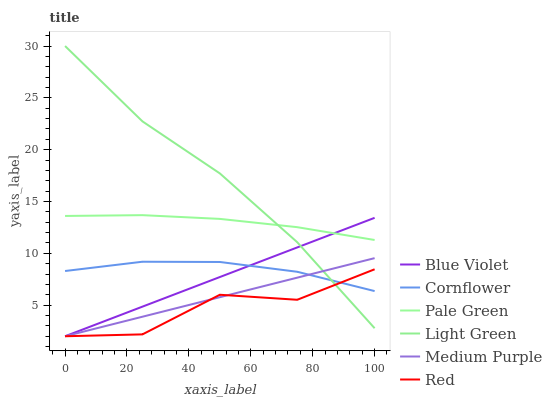Does Red have the minimum area under the curve?
Answer yes or no. Yes. Does Light Green have the maximum area under the curve?
Answer yes or no. Yes. Does Medium Purple have the minimum area under the curve?
Answer yes or no. No. Does Medium Purple have the maximum area under the curve?
Answer yes or no. No. Is Medium Purple the smoothest?
Answer yes or no. Yes. Is Red the roughest?
Answer yes or no. Yes. Is Pale Green the smoothest?
Answer yes or no. No. Is Pale Green the roughest?
Answer yes or no. No. Does Pale Green have the lowest value?
Answer yes or no. No. Does Light Green have the highest value?
Answer yes or no. Yes. Does Medium Purple have the highest value?
Answer yes or no. No. Is Red less than Pale Green?
Answer yes or no. Yes. Is Pale Green greater than Cornflower?
Answer yes or no. Yes. Does Red intersect Blue Violet?
Answer yes or no. Yes. Is Red less than Blue Violet?
Answer yes or no. No. Is Red greater than Blue Violet?
Answer yes or no. No. Does Red intersect Pale Green?
Answer yes or no. No. 